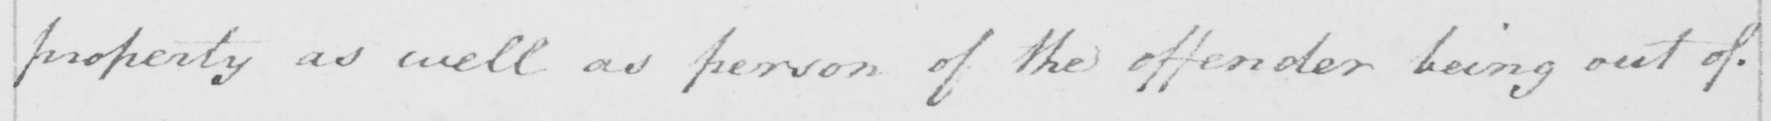What text is written in this handwritten line? property as well as person of the offender being out of 